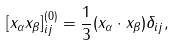Convert formula to latex. <formula><loc_0><loc_0><loc_500><loc_500>[ x _ { \alpha } x _ { \beta } ] ^ { ( 0 ) } _ { i j } = \frac { 1 } { 3 } ( { x } _ { \alpha } \cdot { x } _ { \beta } ) \delta _ { i j } ,</formula> 